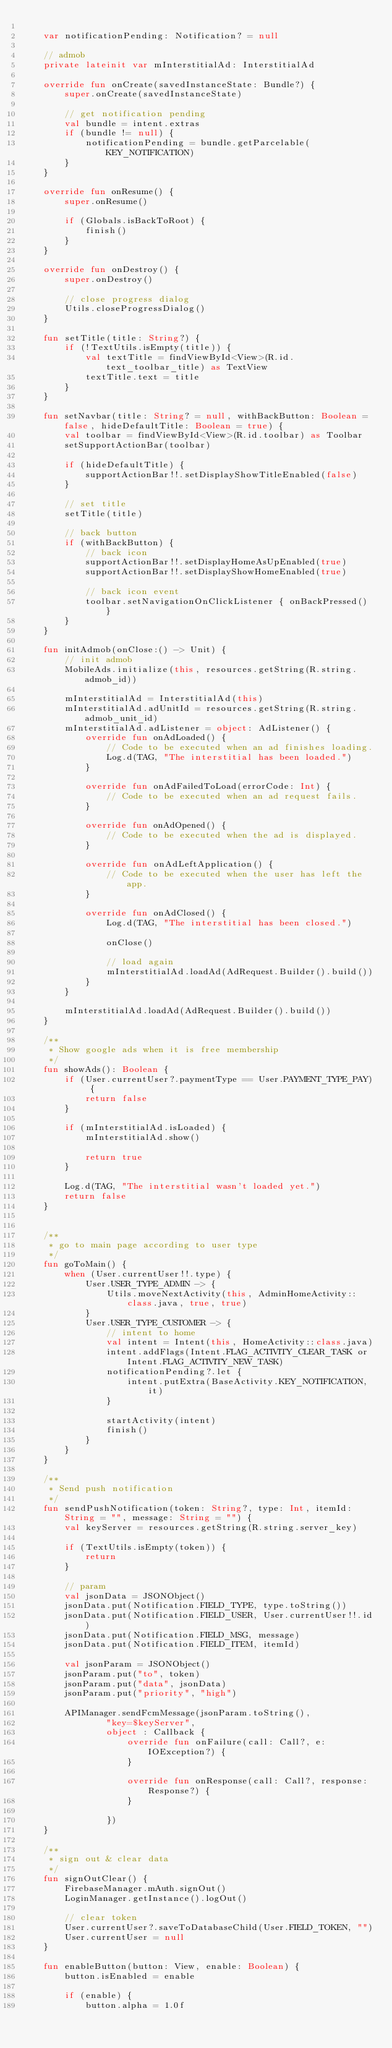<code> <loc_0><loc_0><loc_500><loc_500><_Kotlin_>
    var notificationPending: Notification? = null

    // admob
    private lateinit var mInterstitialAd: InterstitialAd

    override fun onCreate(savedInstanceState: Bundle?) {
        super.onCreate(savedInstanceState)

        // get notification pending
        val bundle = intent.extras
        if (bundle != null) {
            notificationPending = bundle.getParcelable(KEY_NOTIFICATION)
        }
    }

    override fun onResume() {
        super.onResume()

        if (Globals.isBackToRoot) {
            finish()
        }
    }

    override fun onDestroy() {
        super.onDestroy()

        // close progress dialog
        Utils.closeProgressDialog()
    }

    fun setTitle(title: String?) {
        if (!TextUtils.isEmpty(title)) {
            val textTitle = findViewById<View>(R.id.text_toolbar_title) as TextView
            textTitle.text = title
        }
    }

    fun setNavbar(title: String? = null, withBackButton: Boolean = false, hideDefaultTitle: Boolean = true) {
        val toolbar = findViewById<View>(R.id.toolbar) as Toolbar
        setSupportActionBar(toolbar)

        if (hideDefaultTitle) {
            supportActionBar!!.setDisplayShowTitleEnabled(false)
        }

        // set title
        setTitle(title)

        // back button
        if (withBackButton) {
            // back icon
            supportActionBar!!.setDisplayHomeAsUpEnabled(true)
            supportActionBar!!.setDisplayShowHomeEnabled(true)

            // back icon event
            toolbar.setNavigationOnClickListener { onBackPressed() }
        }
    }

    fun initAdmob(onClose:() -> Unit) {
        // init admob
        MobileAds.initialize(this, resources.getString(R.string.admob_id))

        mInterstitialAd = InterstitialAd(this)
        mInterstitialAd.adUnitId = resources.getString(R.string.admob_unit_id)
        mInterstitialAd.adListener = object: AdListener() {
            override fun onAdLoaded() {
                // Code to be executed when an ad finishes loading.
                Log.d(TAG, "The interstitial has been loaded.")
            }

            override fun onAdFailedToLoad(errorCode: Int) {
                // Code to be executed when an ad request fails.
            }

            override fun onAdOpened() {
                // Code to be executed when the ad is displayed.
            }

            override fun onAdLeftApplication() {
                // Code to be executed when the user has left the app.
            }

            override fun onAdClosed() {
                Log.d(TAG, "The interstitial has been closed.")

                onClose()

                // load again
                mInterstitialAd.loadAd(AdRequest.Builder().build())
            }
        }

        mInterstitialAd.loadAd(AdRequest.Builder().build())
    }

    /**
     * Show google ads when it is free membership
     */
    fun showAds(): Boolean {
        if (User.currentUser?.paymentType == User.PAYMENT_TYPE_PAY) {
            return false
        }

        if (mInterstitialAd.isLoaded) {
            mInterstitialAd.show()

            return true
        }

        Log.d(TAG, "The interstitial wasn't loaded yet.")
        return false
    }


    /**
     * go to main page according to user type
     */
    fun goToMain() {
        when (User.currentUser!!.type) {
            User.USER_TYPE_ADMIN -> {
                Utils.moveNextActivity(this, AdminHomeActivity::class.java, true, true)
            }
            User.USER_TYPE_CUSTOMER -> {
                // intent to home
                val intent = Intent(this, HomeActivity::class.java)
                intent.addFlags(Intent.FLAG_ACTIVITY_CLEAR_TASK or Intent.FLAG_ACTIVITY_NEW_TASK)
                notificationPending?.let {
                    intent.putExtra(BaseActivity.KEY_NOTIFICATION, it)
                }

                startActivity(intent)
                finish()
            }
        }
    }

    /**
     * Send push notification
     */
    fun sendPushNotification(token: String?, type: Int, itemId: String = "", message: String = "") {
        val keyServer = resources.getString(R.string.server_key)

        if (TextUtils.isEmpty(token)) {
            return
        }

        // param
        val jsonData = JSONObject()
        jsonData.put(Notification.FIELD_TYPE, type.toString())
        jsonData.put(Notification.FIELD_USER, User.currentUser!!.id)
        jsonData.put(Notification.FIELD_MSG, message)
        jsonData.put(Notification.FIELD_ITEM, itemId)

        val jsonParam = JSONObject()
        jsonParam.put("to", token)
        jsonParam.put("data", jsonData)
        jsonParam.put("priority", "high")

        APIManager.sendFcmMessage(jsonParam.toString(),
                "key=$keyServer",
                object : Callback {
                    override fun onFailure(call: Call?, e: IOException?) {
                    }

                    override fun onResponse(call: Call?, response: Response?) {
                    }

                })
    }

    /**
     * sign out & clear data
     */
    fun signOutClear() {
        FirebaseManager.mAuth.signOut()
        LoginManager.getInstance().logOut()

        // clear token
        User.currentUser?.saveToDatabaseChild(User.FIELD_TOKEN, "")
        User.currentUser = null
    }

    fun enableButton(button: View, enable: Boolean) {
        button.isEnabled = enable

        if (enable) {
            button.alpha = 1.0f</code> 